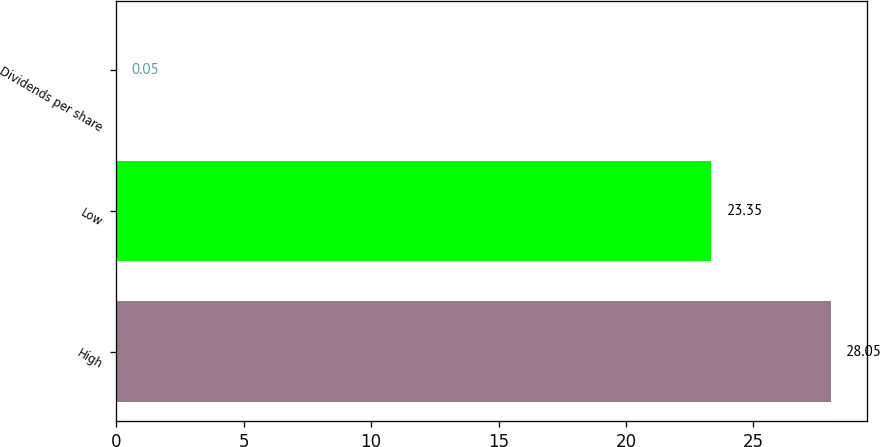Convert chart. <chart><loc_0><loc_0><loc_500><loc_500><bar_chart><fcel>High<fcel>Low<fcel>Dividends per share<nl><fcel>28.05<fcel>23.35<fcel>0.05<nl></chart> 